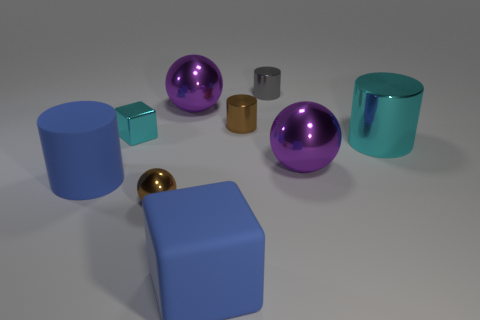How many things are purple metallic spheres or objects that are to the left of the cyan metallic block?
Make the answer very short. 3. There is a cyan thing that is the same size as the blue rubber cube; what material is it?
Provide a succinct answer. Metal. Does the big cyan thing have the same material as the brown sphere?
Offer a very short reply. Yes. What is the color of the object that is both to the left of the small brown metal ball and behind the large cyan cylinder?
Your response must be concise. Cyan. Does the large rubber cylinder that is in front of the tiny cyan object have the same color as the metal cube?
Provide a succinct answer. No. What shape is the cyan object that is the same size as the blue rubber cylinder?
Offer a very short reply. Cylinder. What number of other things are the same color as the rubber block?
Provide a short and direct response. 1. How many other objects are the same material as the small cyan cube?
Provide a short and direct response. 6. Does the blue cylinder have the same size as the purple metallic sphere to the right of the tiny gray shiny object?
Provide a short and direct response. Yes. What color is the large rubber cylinder?
Provide a succinct answer. Blue. 